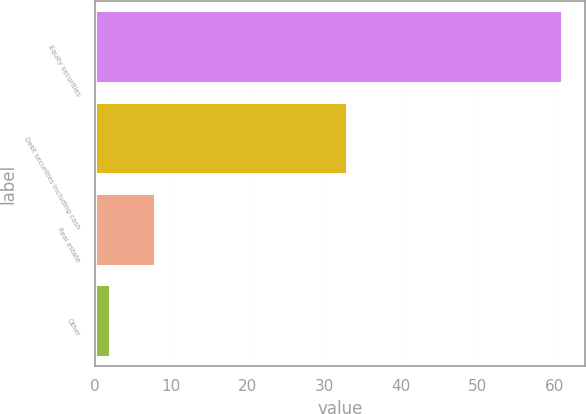<chart> <loc_0><loc_0><loc_500><loc_500><bar_chart><fcel>Equity securities<fcel>Debt securities including cash<fcel>Real estate<fcel>Other<nl><fcel>61<fcel>33<fcel>7.9<fcel>2<nl></chart> 